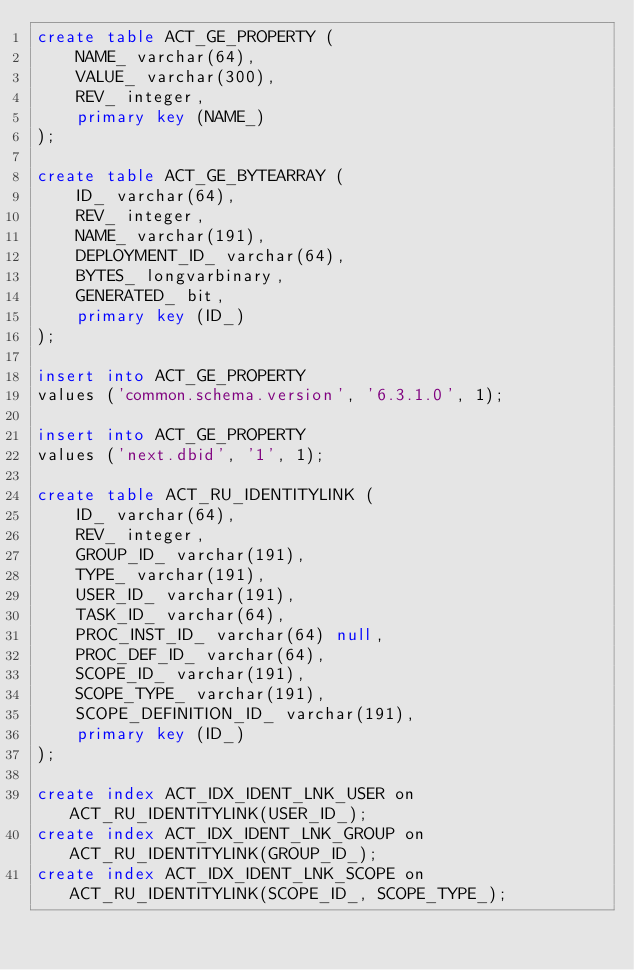Convert code to text. <code><loc_0><loc_0><loc_500><loc_500><_SQL_>create table ACT_GE_PROPERTY (
    NAME_ varchar(64),
    VALUE_ varchar(300),
    REV_ integer,
    primary key (NAME_)
);

create table ACT_GE_BYTEARRAY (
    ID_ varchar(64),
    REV_ integer,
    NAME_ varchar(191),
    DEPLOYMENT_ID_ varchar(64),
    BYTES_ longvarbinary,
    GENERATED_ bit,
    primary key (ID_)
);

insert into ACT_GE_PROPERTY
values ('common.schema.version', '6.3.1.0', 1);

insert into ACT_GE_PROPERTY
values ('next.dbid', '1', 1);

create table ACT_RU_IDENTITYLINK (
    ID_ varchar(64),
    REV_ integer,
    GROUP_ID_ varchar(191),
    TYPE_ varchar(191),
    USER_ID_ varchar(191),
    TASK_ID_ varchar(64),
    PROC_INST_ID_ varchar(64) null,
    PROC_DEF_ID_ varchar(64),
    SCOPE_ID_ varchar(191),
    SCOPE_TYPE_ varchar(191),
    SCOPE_DEFINITION_ID_ varchar(191),
    primary key (ID_)
);

create index ACT_IDX_IDENT_LNK_USER on ACT_RU_IDENTITYLINK(USER_ID_);
create index ACT_IDX_IDENT_LNK_GROUP on ACT_RU_IDENTITYLINK(GROUP_ID_);
create index ACT_IDX_IDENT_LNK_SCOPE on ACT_RU_IDENTITYLINK(SCOPE_ID_, SCOPE_TYPE_);</code> 